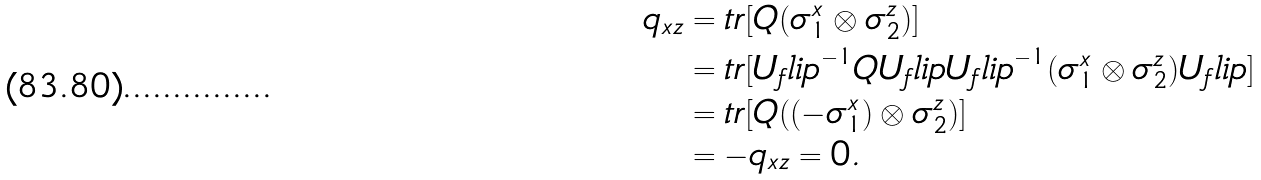<formula> <loc_0><loc_0><loc_500><loc_500>q _ { x z } & = t r [ Q ( \sigma _ { 1 } ^ { x } \otimes \sigma _ { 2 } ^ { z } ) ] \\ & = t r [ { U _ { f } l i p } ^ { - 1 } Q U _ { f } l i p { U _ { f } l i p } ^ { - 1 } ( \sigma _ { 1 } ^ { x } \otimes \sigma _ { 2 } ^ { z } ) U _ { f } l i p ] \\ & = t r [ Q ( ( - \sigma _ { 1 } ^ { x } ) \otimes \sigma _ { 2 } ^ { z } ) ] \\ & = - q _ { x z } = 0 .</formula> 